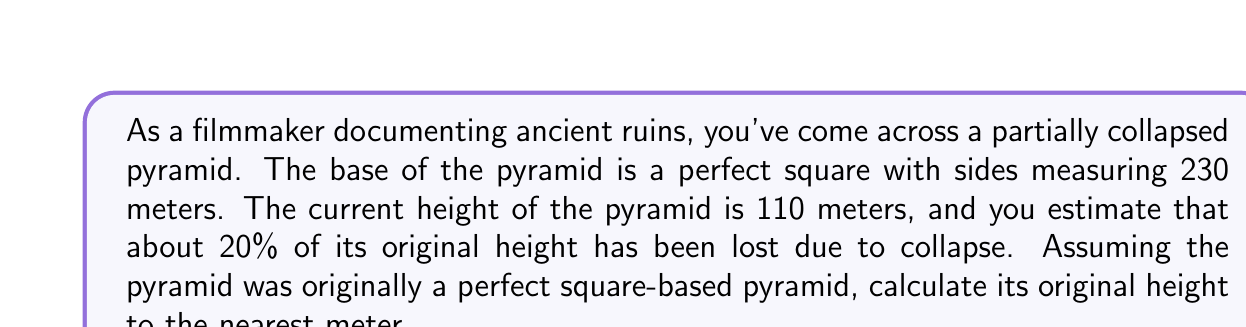Can you solve this math problem? Let's approach this step-by-step:

1) First, we need to understand the relationship between the base, height, and slope of a square-based pyramid. The key here is the ratio of height to half the base length, which remains constant.

2) Let's define our variables:
   $b$ = length of base side = 230 m
   $h$ = current height = 110 m
   $H$ = original height (what we're solving for)

3) We know that the current height is 80% of the original height (since 20% was lost). We can express this as:

   $h = 0.8H$

4) Now, let's consider the ratio of height to half the base length. This ratio is the same for both the current and original pyramid:

   $$\frac{h}{b/2} = \frac{H}{b/2}$$

5) Substituting what we know:

   $$\frac{110}{230/2} = \frac{H}{230/2}$$

6) Simplify:

   $$\frac{110}{115} = \frac{H}{115}$$

7) Cross multiply:

   $110 \cdot 115 = 115H$

8) Solve for $H$:

   $H = \frac{110 \cdot 115}{115} = 110$ m

9) But remember, this is only 80% of the original height. To get the original height, we need to divide by 0.8:

   $\text{Original Height} = \frac{110}{0.8} = 137.5$ m

10) Rounding to the nearest meter:

    $\text{Original Height} \approx 138$ m
Answer: 138 m 